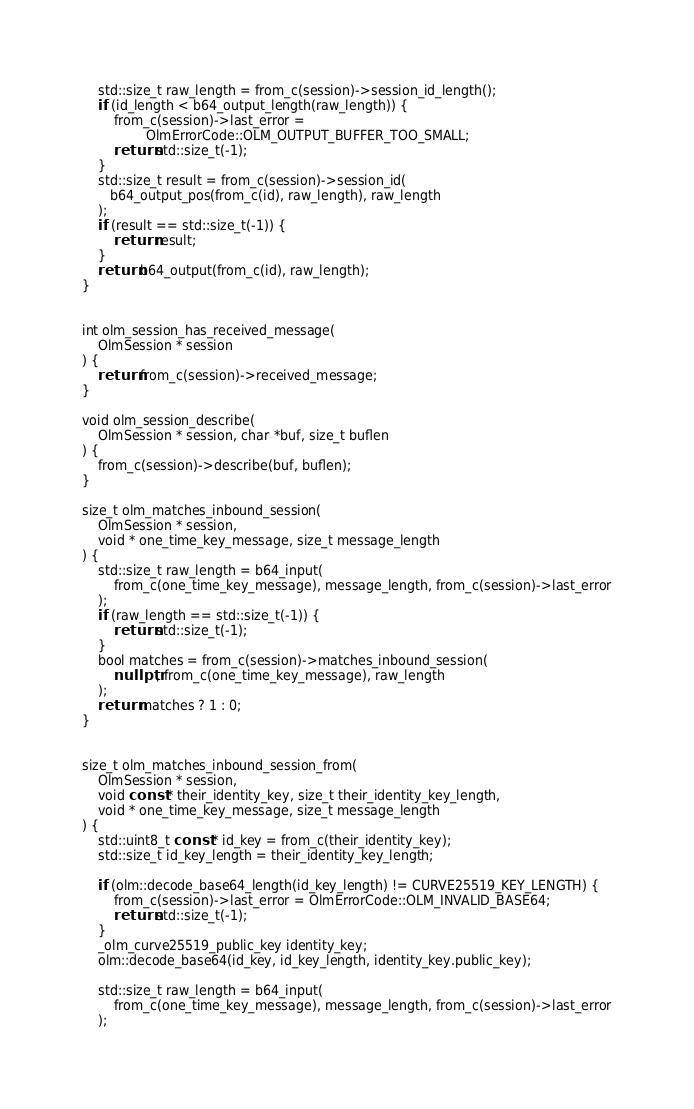Convert code to text. <code><loc_0><loc_0><loc_500><loc_500><_C++_>    std::size_t raw_length = from_c(session)->session_id_length();
    if (id_length < b64_output_length(raw_length)) {
        from_c(session)->last_error =
                OlmErrorCode::OLM_OUTPUT_BUFFER_TOO_SMALL;
        return std::size_t(-1);
    }
    std::size_t result = from_c(session)->session_id(
       b64_output_pos(from_c(id), raw_length), raw_length
    );
    if (result == std::size_t(-1)) {
        return result;
    }
    return b64_output(from_c(id), raw_length);
}


int olm_session_has_received_message(
    OlmSession * session
) {
    return from_c(session)->received_message;
}

void olm_session_describe(
    OlmSession * session, char *buf, size_t buflen
) {
    from_c(session)->describe(buf, buflen);
}

size_t olm_matches_inbound_session(
    OlmSession * session,
    void * one_time_key_message, size_t message_length
) {
    std::size_t raw_length = b64_input(
        from_c(one_time_key_message), message_length, from_c(session)->last_error
    );
    if (raw_length == std::size_t(-1)) {
        return std::size_t(-1);
    }
    bool matches = from_c(session)->matches_inbound_session(
        nullptr, from_c(one_time_key_message), raw_length
    );
    return matches ? 1 : 0;
}


size_t olm_matches_inbound_session_from(
    OlmSession * session,
    void const * their_identity_key, size_t their_identity_key_length,
    void * one_time_key_message, size_t message_length
) {
    std::uint8_t const * id_key = from_c(their_identity_key);
    std::size_t id_key_length = their_identity_key_length;

    if (olm::decode_base64_length(id_key_length) != CURVE25519_KEY_LENGTH) {
        from_c(session)->last_error = OlmErrorCode::OLM_INVALID_BASE64;
        return std::size_t(-1);
    }
    _olm_curve25519_public_key identity_key;
    olm::decode_base64(id_key, id_key_length, identity_key.public_key);

    std::size_t raw_length = b64_input(
        from_c(one_time_key_message), message_length, from_c(session)->last_error
    );</code> 